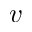<formula> <loc_0><loc_0><loc_500><loc_500>v</formula> 